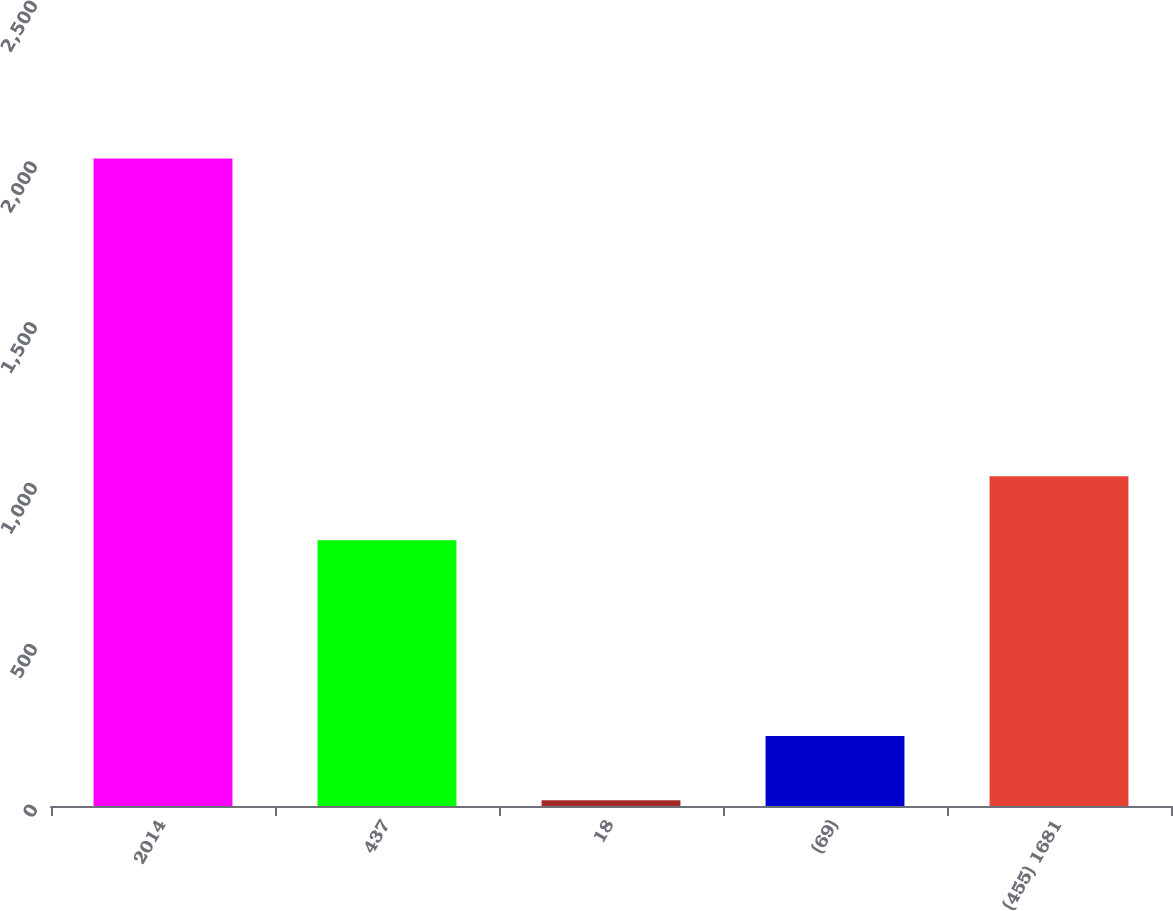Convert chart to OTSL. <chart><loc_0><loc_0><loc_500><loc_500><bar_chart><fcel>2014<fcel>437<fcel>18<fcel>(69)<fcel>(455) 1681<nl><fcel>2013<fcel>826<fcel>18<fcel>217.5<fcel>1025.5<nl></chart> 